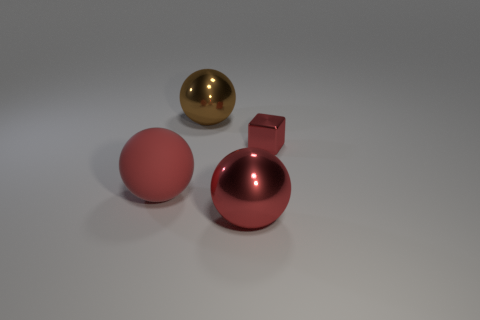What number of other objects are the same color as the big matte sphere?
Your response must be concise. 2. Is the number of large red rubber balls that are to the right of the small metallic thing less than the number of tiny purple shiny spheres?
Offer a terse response. No. There is a big metal thing that is in front of the large shiny thing that is left of the large metallic thing in front of the red block; what color is it?
Your response must be concise. Red. Is there any other thing that is made of the same material as the small red block?
Offer a terse response. Yes. There is another shiny thing that is the same shape as the brown shiny thing; what size is it?
Offer a very short reply. Large. Are there fewer red blocks that are in front of the large matte thing than tiny red shiny blocks right of the red shiny cube?
Keep it short and to the point. No. What shape is the shiny thing that is behind the red rubber object and right of the large brown object?
Give a very brief answer. Cube. What is the size of the other ball that is the same material as the brown sphere?
Your response must be concise. Large. Do the small cube and the big shiny ball behind the red matte thing have the same color?
Your response must be concise. No. What is the thing that is behind the large matte sphere and in front of the big brown shiny sphere made of?
Your answer should be very brief. Metal. 